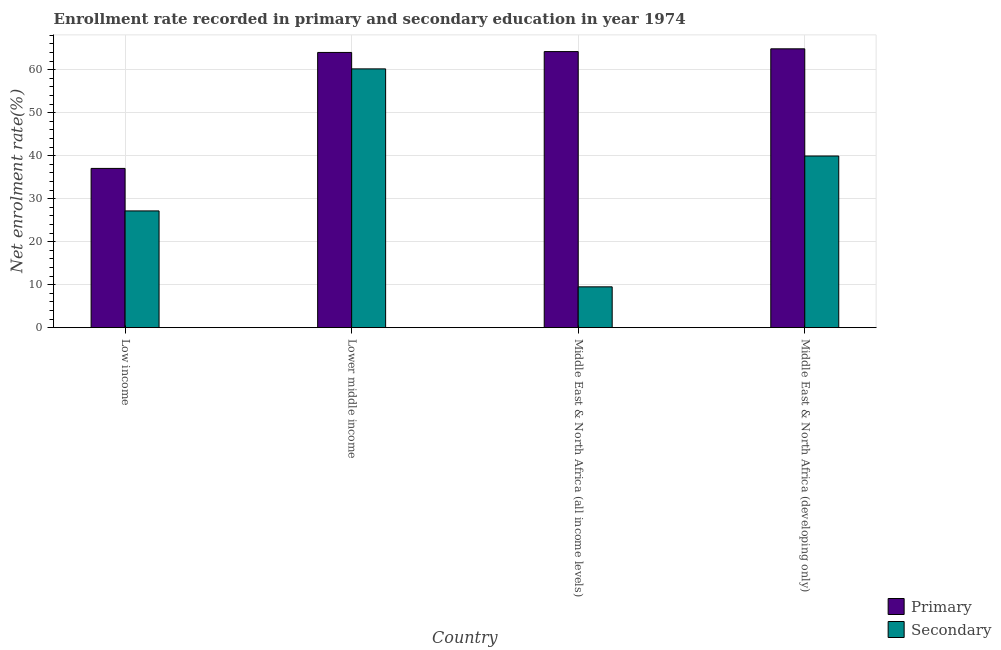How many different coloured bars are there?
Give a very brief answer. 2. How many groups of bars are there?
Offer a very short reply. 4. Are the number of bars per tick equal to the number of legend labels?
Offer a terse response. Yes. Are the number of bars on each tick of the X-axis equal?
Give a very brief answer. Yes. How many bars are there on the 1st tick from the left?
Keep it short and to the point. 2. How many bars are there on the 3rd tick from the right?
Offer a terse response. 2. What is the label of the 4th group of bars from the left?
Provide a short and direct response. Middle East & North Africa (developing only). In how many cases, is the number of bars for a given country not equal to the number of legend labels?
Provide a short and direct response. 0. What is the enrollment rate in secondary education in Middle East & North Africa (all income levels)?
Provide a succinct answer. 9.5. Across all countries, what is the maximum enrollment rate in primary education?
Your response must be concise. 64.86. Across all countries, what is the minimum enrollment rate in primary education?
Make the answer very short. 37.04. In which country was the enrollment rate in secondary education maximum?
Give a very brief answer. Lower middle income. In which country was the enrollment rate in secondary education minimum?
Your answer should be compact. Middle East & North Africa (all income levels). What is the total enrollment rate in primary education in the graph?
Your answer should be compact. 230.14. What is the difference between the enrollment rate in secondary education in Lower middle income and that in Middle East & North Africa (developing only)?
Make the answer very short. 20.27. What is the difference between the enrollment rate in primary education in Lower middle income and the enrollment rate in secondary education in Middle East & North Africa (developing only)?
Provide a succinct answer. 24.09. What is the average enrollment rate in primary education per country?
Offer a very short reply. 57.54. What is the difference between the enrollment rate in primary education and enrollment rate in secondary education in Middle East & North Africa (developing only)?
Provide a short and direct response. 24.93. What is the ratio of the enrollment rate in secondary education in Lower middle income to that in Middle East & North Africa (all income levels)?
Provide a succinct answer. 6.34. What is the difference between the highest and the second highest enrollment rate in secondary education?
Keep it short and to the point. 20.27. What is the difference between the highest and the lowest enrollment rate in secondary education?
Your answer should be compact. 50.7. In how many countries, is the enrollment rate in secondary education greater than the average enrollment rate in secondary education taken over all countries?
Your answer should be compact. 2. What does the 1st bar from the left in Middle East & North Africa (all income levels) represents?
Give a very brief answer. Primary. What does the 2nd bar from the right in Middle East & North Africa (all income levels) represents?
Keep it short and to the point. Primary. What is the difference between two consecutive major ticks on the Y-axis?
Your answer should be very brief. 10. Are the values on the major ticks of Y-axis written in scientific E-notation?
Give a very brief answer. No. Where does the legend appear in the graph?
Provide a short and direct response. Bottom right. How many legend labels are there?
Your answer should be compact. 2. How are the legend labels stacked?
Make the answer very short. Vertical. What is the title of the graph?
Offer a very short reply. Enrollment rate recorded in primary and secondary education in year 1974. What is the label or title of the X-axis?
Provide a short and direct response. Country. What is the label or title of the Y-axis?
Offer a very short reply. Net enrolment rate(%). What is the Net enrolment rate(%) of Primary in Low income?
Offer a very short reply. 37.04. What is the Net enrolment rate(%) of Secondary in Low income?
Your answer should be compact. 27.16. What is the Net enrolment rate(%) of Primary in Lower middle income?
Offer a very short reply. 64.02. What is the Net enrolment rate(%) of Secondary in Lower middle income?
Make the answer very short. 60.2. What is the Net enrolment rate(%) of Primary in Middle East & North Africa (all income levels)?
Keep it short and to the point. 64.22. What is the Net enrolment rate(%) of Secondary in Middle East & North Africa (all income levels)?
Keep it short and to the point. 9.5. What is the Net enrolment rate(%) in Primary in Middle East & North Africa (developing only)?
Ensure brevity in your answer.  64.86. What is the Net enrolment rate(%) in Secondary in Middle East & North Africa (developing only)?
Give a very brief answer. 39.93. Across all countries, what is the maximum Net enrolment rate(%) of Primary?
Your answer should be very brief. 64.86. Across all countries, what is the maximum Net enrolment rate(%) of Secondary?
Keep it short and to the point. 60.2. Across all countries, what is the minimum Net enrolment rate(%) of Primary?
Make the answer very short. 37.04. Across all countries, what is the minimum Net enrolment rate(%) in Secondary?
Offer a very short reply. 9.5. What is the total Net enrolment rate(%) of Primary in the graph?
Your answer should be compact. 230.14. What is the total Net enrolment rate(%) in Secondary in the graph?
Offer a very short reply. 136.78. What is the difference between the Net enrolment rate(%) in Primary in Low income and that in Lower middle income?
Your answer should be very brief. -26.98. What is the difference between the Net enrolment rate(%) in Secondary in Low income and that in Lower middle income?
Your response must be concise. -33.04. What is the difference between the Net enrolment rate(%) in Primary in Low income and that in Middle East & North Africa (all income levels)?
Ensure brevity in your answer.  -27.18. What is the difference between the Net enrolment rate(%) of Secondary in Low income and that in Middle East & North Africa (all income levels)?
Provide a short and direct response. 17.66. What is the difference between the Net enrolment rate(%) of Primary in Low income and that in Middle East & North Africa (developing only)?
Offer a very short reply. -27.82. What is the difference between the Net enrolment rate(%) of Secondary in Low income and that in Middle East & North Africa (developing only)?
Provide a succinct answer. -12.77. What is the difference between the Net enrolment rate(%) of Primary in Lower middle income and that in Middle East & North Africa (all income levels)?
Keep it short and to the point. -0.2. What is the difference between the Net enrolment rate(%) in Secondary in Lower middle income and that in Middle East & North Africa (all income levels)?
Give a very brief answer. 50.7. What is the difference between the Net enrolment rate(%) in Primary in Lower middle income and that in Middle East & North Africa (developing only)?
Your response must be concise. -0.84. What is the difference between the Net enrolment rate(%) of Secondary in Lower middle income and that in Middle East & North Africa (developing only)?
Your answer should be compact. 20.27. What is the difference between the Net enrolment rate(%) of Primary in Middle East & North Africa (all income levels) and that in Middle East & North Africa (developing only)?
Make the answer very short. -0.64. What is the difference between the Net enrolment rate(%) of Secondary in Middle East & North Africa (all income levels) and that in Middle East & North Africa (developing only)?
Provide a short and direct response. -30.43. What is the difference between the Net enrolment rate(%) of Primary in Low income and the Net enrolment rate(%) of Secondary in Lower middle income?
Give a very brief answer. -23.15. What is the difference between the Net enrolment rate(%) in Primary in Low income and the Net enrolment rate(%) in Secondary in Middle East & North Africa (all income levels)?
Ensure brevity in your answer.  27.55. What is the difference between the Net enrolment rate(%) of Primary in Low income and the Net enrolment rate(%) of Secondary in Middle East & North Africa (developing only)?
Ensure brevity in your answer.  -2.89. What is the difference between the Net enrolment rate(%) in Primary in Lower middle income and the Net enrolment rate(%) in Secondary in Middle East & North Africa (all income levels)?
Make the answer very short. 54.52. What is the difference between the Net enrolment rate(%) of Primary in Lower middle income and the Net enrolment rate(%) of Secondary in Middle East & North Africa (developing only)?
Offer a terse response. 24.09. What is the difference between the Net enrolment rate(%) of Primary in Middle East & North Africa (all income levels) and the Net enrolment rate(%) of Secondary in Middle East & North Africa (developing only)?
Offer a terse response. 24.29. What is the average Net enrolment rate(%) in Primary per country?
Offer a terse response. 57.54. What is the average Net enrolment rate(%) in Secondary per country?
Your answer should be very brief. 34.19. What is the difference between the Net enrolment rate(%) in Primary and Net enrolment rate(%) in Secondary in Low income?
Keep it short and to the point. 9.89. What is the difference between the Net enrolment rate(%) in Primary and Net enrolment rate(%) in Secondary in Lower middle income?
Your response must be concise. 3.82. What is the difference between the Net enrolment rate(%) of Primary and Net enrolment rate(%) of Secondary in Middle East & North Africa (all income levels)?
Ensure brevity in your answer.  54.72. What is the difference between the Net enrolment rate(%) in Primary and Net enrolment rate(%) in Secondary in Middle East & North Africa (developing only)?
Your answer should be compact. 24.93. What is the ratio of the Net enrolment rate(%) of Primary in Low income to that in Lower middle income?
Make the answer very short. 0.58. What is the ratio of the Net enrolment rate(%) in Secondary in Low income to that in Lower middle income?
Keep it short and to the point. 0.45. What is the ratio of the Net enrolment rate(%) in Primary in Low income to that in Middle East & North Africa (all income levels)?
Give a very brief answer. 0.58. What is the ratio of the Net enrolment rate(%) of Secondary in Low income to that in Middle East & North Africa (all income levels)?
Your answer should be very brief. 2.86. What is the ratio of the Net enrolment rate(%) in Primary in Low income to that in Middle East & North Africa (developing only)?
Your answer should be compact. 0.57. What is the ratio of the Net enrolment rate(%) in Secondary in Low income to that in Middle East & North Africa (developing only)?
Your answer should be compact. 0.68. What is the ratio of the Net enrolment rate(%) of Primary in Lower middle income to that in Middle East & North Africa (all income levels)?
Give a very brief answer. 1. What is the ratio of the Net enrolment rate(%) in Secondary in Lower middle income to that in Middle East & North Africa (all income levels)?
Your answer should be compact. 6.34. What is the ratio of the Net enrolment rate(%) of Primary in Lower middle income to that in Middle East & North Africa (developing only)?
Keep it short and to the point. 0.99. What is the ratio of the Net enrolment rate(%) of Secondary in Lower middle income to that in Middle East & North Africa (developing only)?
Provide a succinct answer. 1.51. What is the ratio of the Net enrolment rate(%) in Secondary in Middle East & North Africa (all income levels) to that in Middle East & North Africa (developing only)?
Offer a terse response. 0.24. What is the difference between the highest and the second highest Net enrolment rate(%) of Primary?
Provide a short and direct response. 0.64. What is the difference between the highest and the second highest Net enrolment rate(%) of Secondary?
Provide a succinct answer. 20.27. What is the difference between the highest and the lowest Net enrolment rate(%) in Primary?
Keep it short and to the point. 27.82. What is the difference between the highest and the lowest Net enrolment rate(%) of Secondary?
Provide a short and direct response. 50.7. 